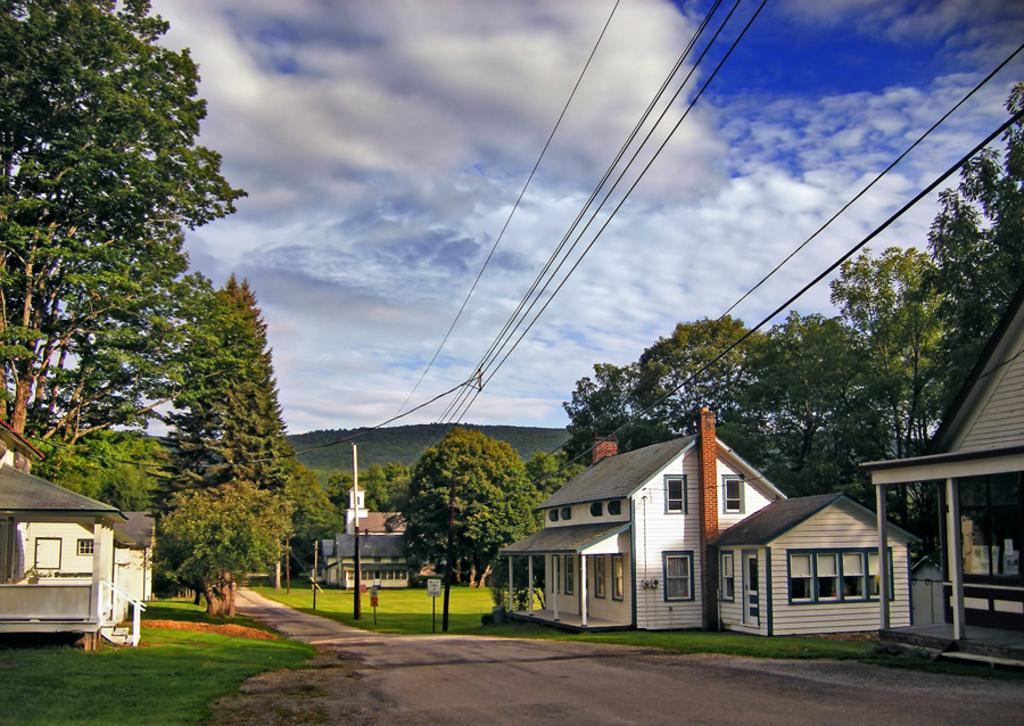What type of structures can be seen in the image? There are buildings in the image. What else can be seen in the image besides buildings? There are poles, wires, trees, and grass visible in the image. What is visible in the background of the image? There are clouds and the sky visible in the background of the image. What type of guitar is being played in the image? There is no guitar present in the image. What songs can be heard in the background of the image? There is no audio or indication of any songs in the image. 